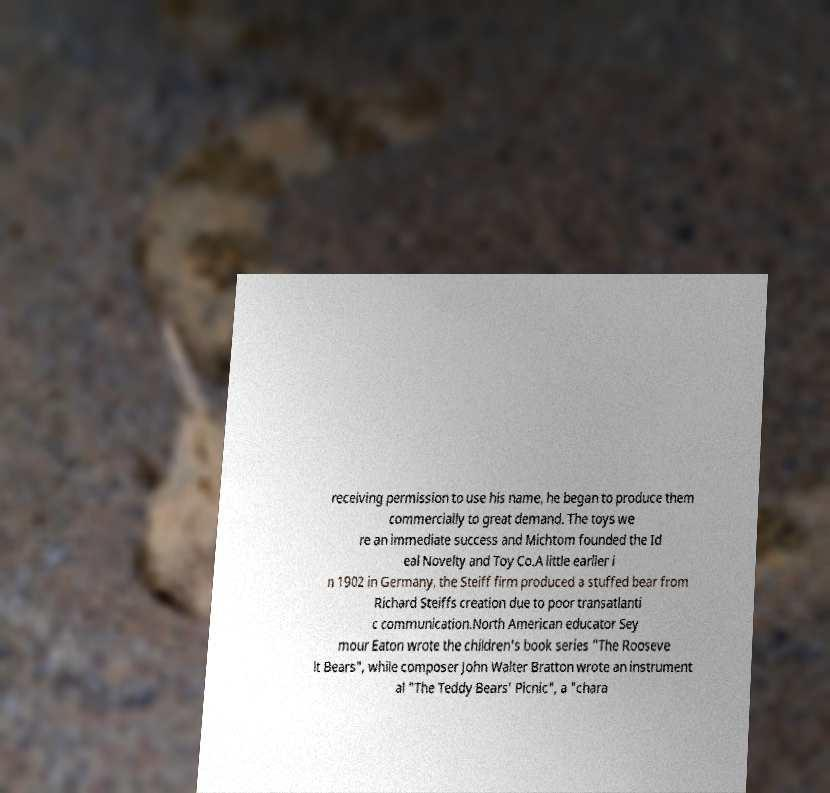For documentation purposes, I need the text within this image transcribed. Could you provide that? receiving permission to use his name, he began to produce them commercially to great demand. The toys we re an immediate success and Michtom founded the Id eal Novelty and Toy Co.A little earlier i n 1902 in Germany, the Steiff firm produced a stuffed bear from Richard Steiffs creation due to poor transatlanti c communication.North American educator Sey mour Eaton wrote the children's book series "The Rooseve lt Bears", while composer John Walter Bratton wrote an instrument al "The Teddy Bears' Picnic", a "chara 